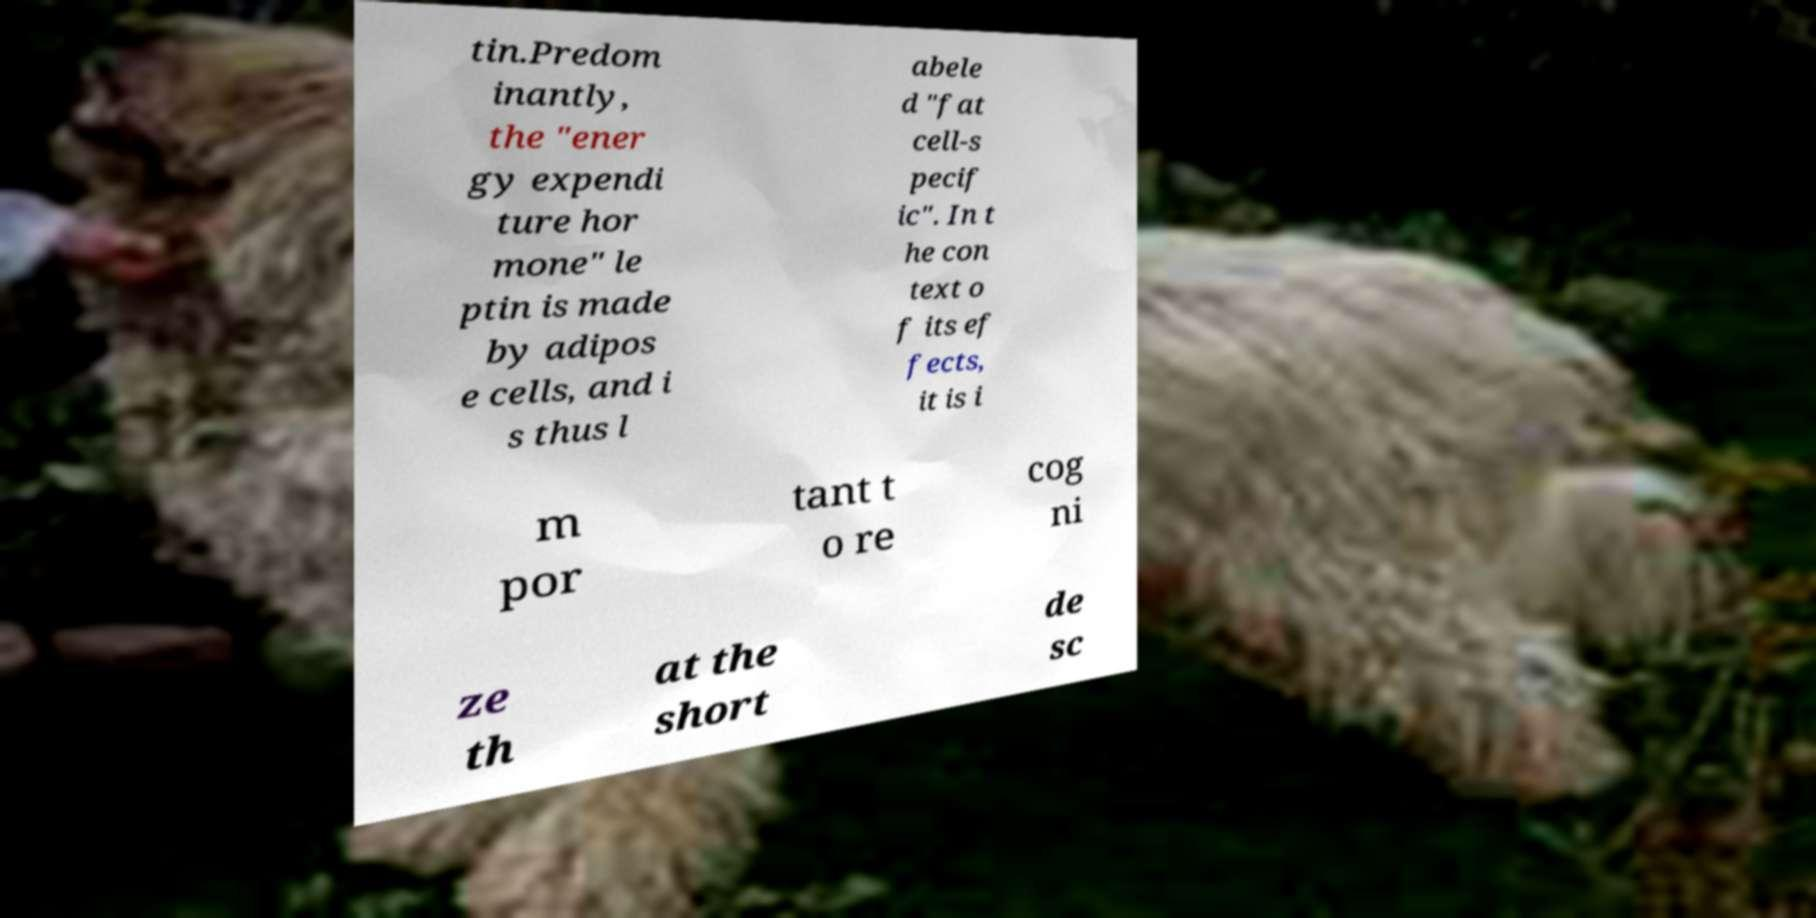Could you extract and type out the text from this image? tin.Predom inantly, the "ener gy expendi ture hor mone" le ptin is made by adipos e cells, and i s thus l abele d "fat cell-s pecif ic". In t he con text o f its ef fects, it is i m por tant t o re cog ni ze th at the short de sc 